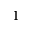<formula> <loc_0><loc_0><loc_500><loc_500>^ { 1 }</formula> 